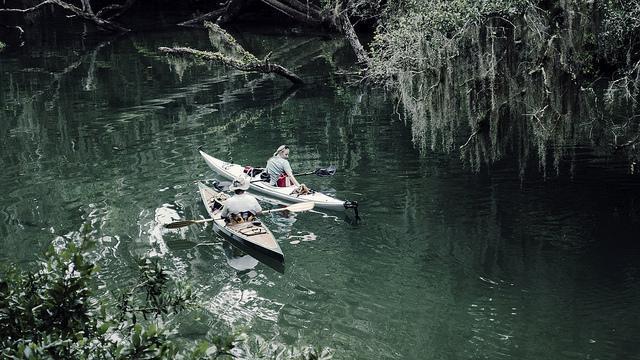How many humans are there?
Give a very brief answer. 2. How many boats?
Give a very brief answer. 2. How many boats are in the photo?
Give a very brief answer. 1. How many people have ties on?
Give a very brief answer. 0. 